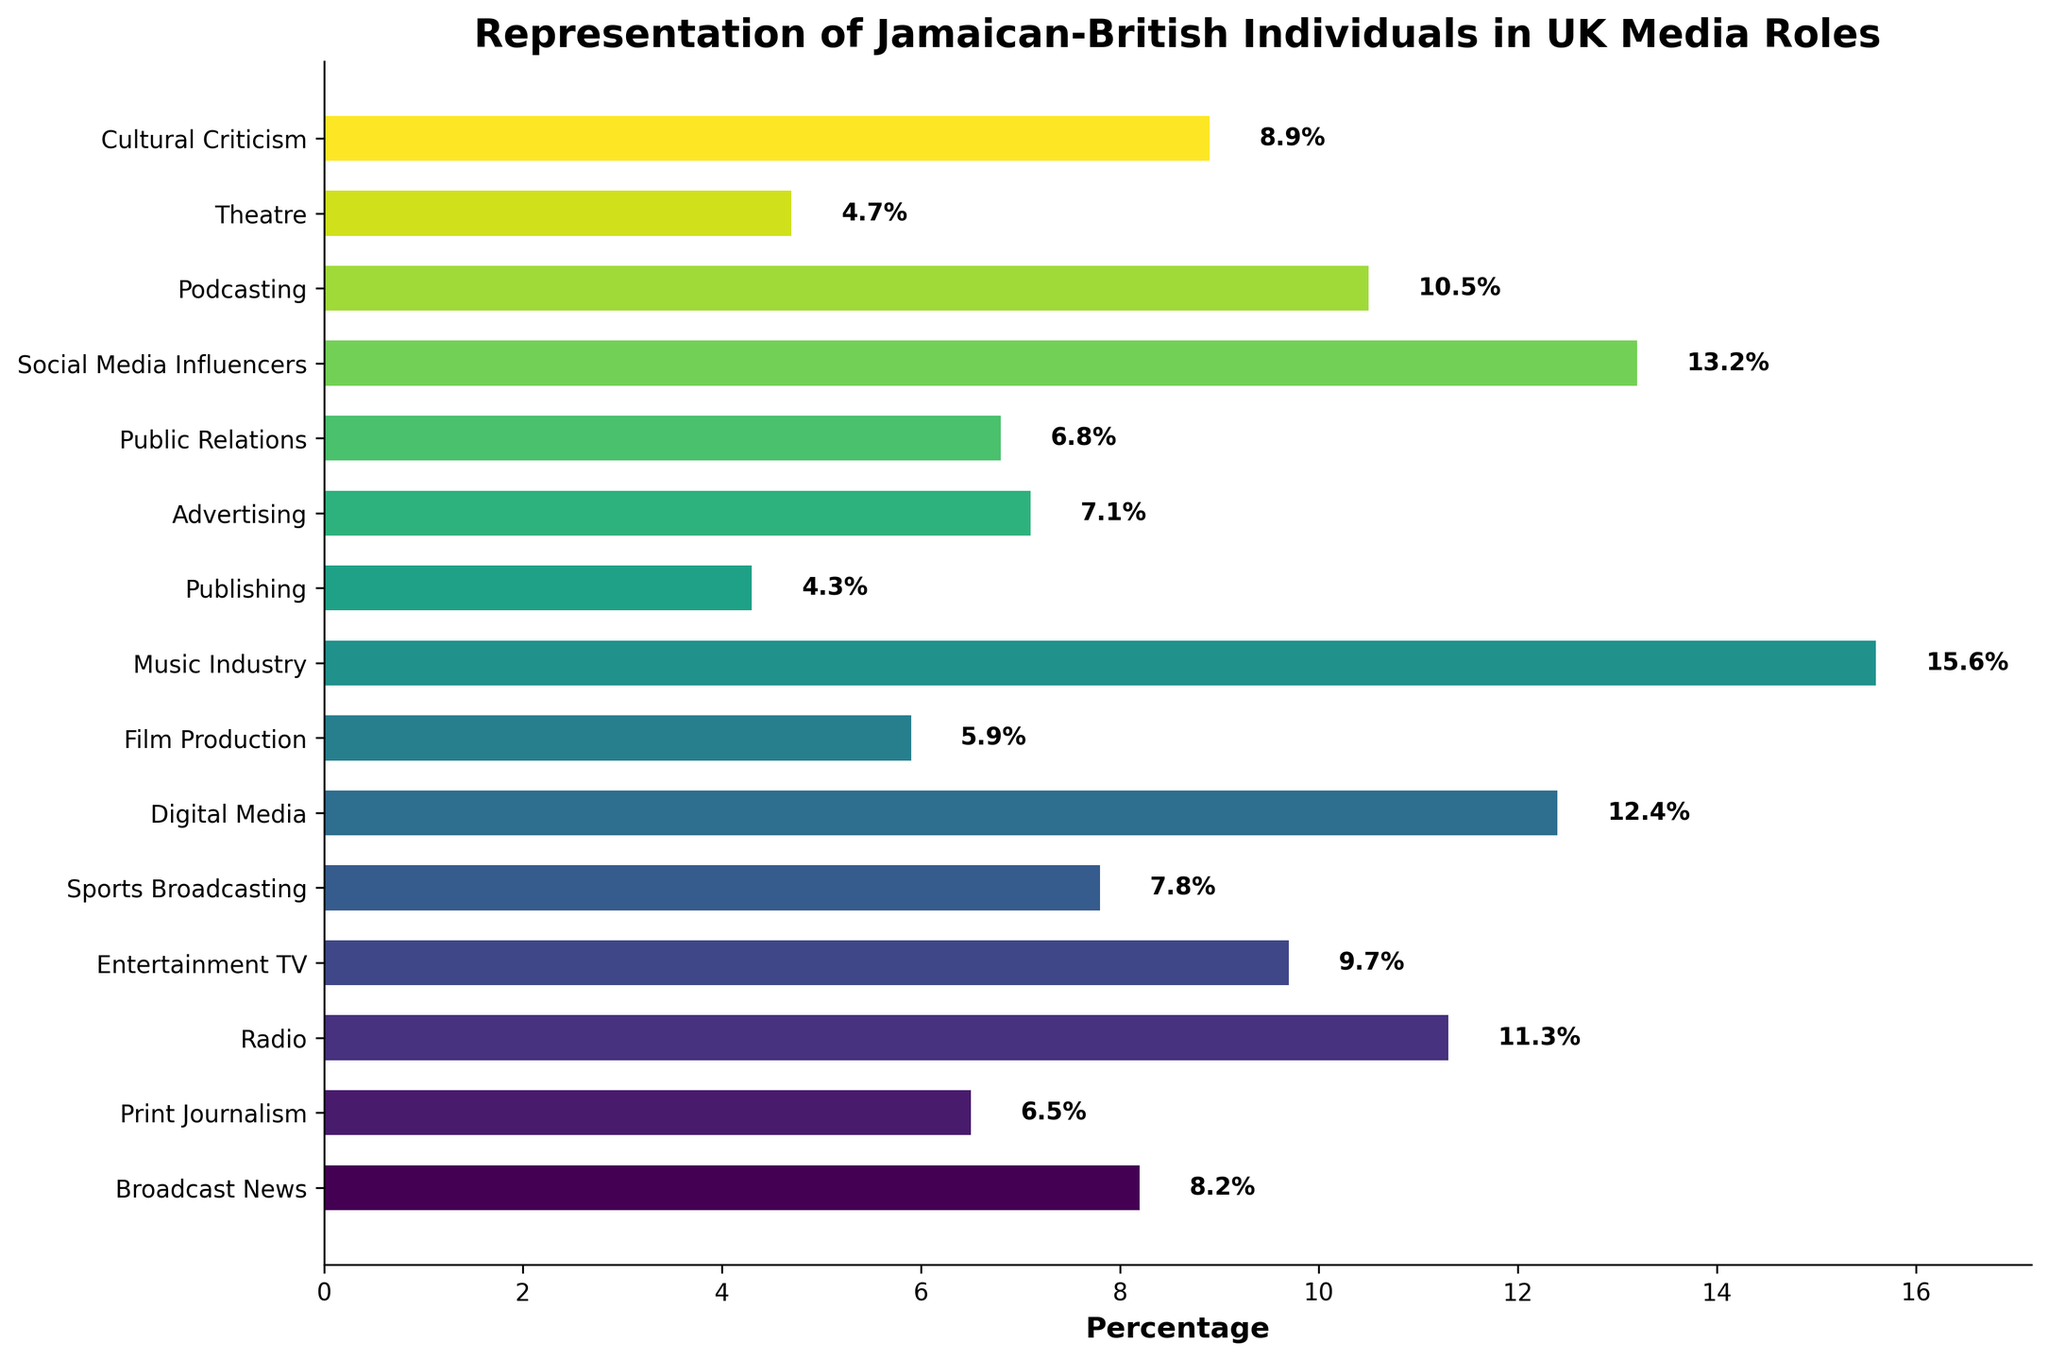Which industry has the highest percentage of Jamaican-British representation? In the figure, the bar representing the Music Industry extends the furthest to the right, indicating it has the highest percentage.
Answer: Music Industry Which industry has the lowest representation of Jamaican-British individuals? Visually, the Publishing bar is the shortest, indicating it has the lowest percentage among the industries listed.
Answer: Publishing How much higher is the representation in Digital Media compared to Print Journalism? The percentage of Jamaican-British individuals in Digital Media is 12.4%, and in Print Journalism, it is 6.5%. The difference is 12.4% - 6.5%.
Answer: 5.9% Compare the representation in Social Media Influencers and Podcasting. Which has a higher percentage? The Social Media Influencers bar is longer than that of Podcasting, indicating a higher percentage.
Answer: Social Media Influencers What is the combined representation percentage of Jamaican-British individuals in Sports Broadcasting and Public Relations? The percentages are 7.8% for Sports Broadcasting and 6.8% for Public Relations. Adding them up gives 7.8% + 6.8%.
Answer: 14.6% Is the representation in Radio higher or lower than in Broadcasting News? By how much? The percentage in Radio is 11.3%, while in Broadcast News, it is 8.2%. The difference is 11.3% - 8.2%.
Answer: Higher by 3.1% What is the average representation of Jamaican-British individuals in the Entertainment TV, Sports Broadcasting, and Theatre industries? The percentages are 9.7%, 7.8%, and 4.7%, respectively. The average is (9.7 + 7.8 + 4.7) / 3.
Answer: 7.4% Which three industries have the closest percentages of Jamaican-British representation? Comparing the bars visually, Broadcast News (8.2%), Sports Broadcasting (7.8%), and Advertising (7.1%) have close percentages.
Answer: Broadcast News, Sports Broadcasting, Advertising Between Film Production and Cultural Criticism, which industry shows a higher representation and by what difference? Film Production has 5.9%, while Cultural Criticism has 8.9%. The difference is 8.9% - 5.9%.
Answer: Cultural Criticism, by 3% 